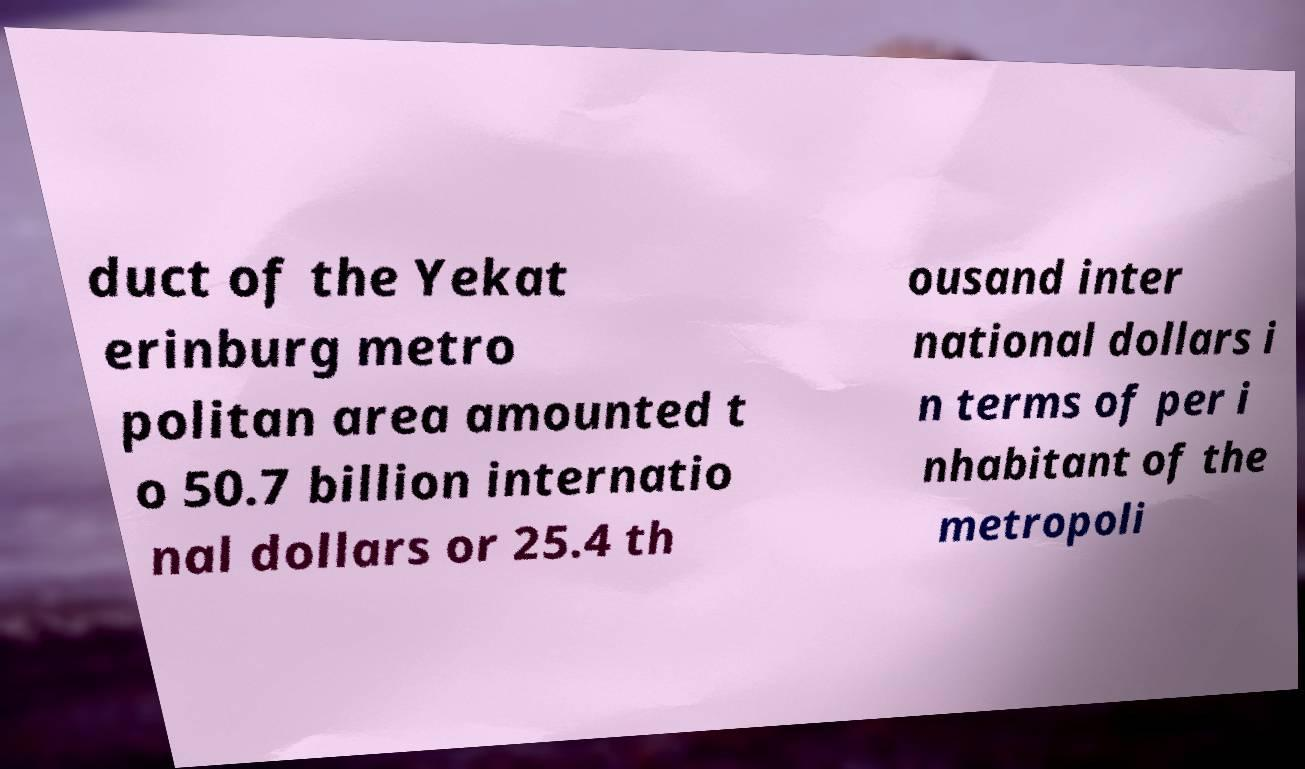Please identify and transcribe the text found in this image. duct of the Yekat erinburg metro politan area amounted t o 50.7 billion internatio nal dollars or 25.4 th ousand inter national dollars i n terms of per i nhabitant of the metropoli 